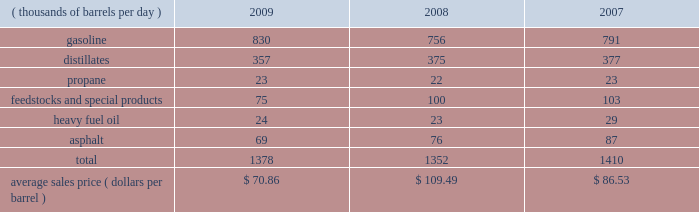The table sets forth our refined products sales by product group and our average sales price for each of the last three years .
Refined product sales ( thousands of barrels per day ) 2009 2008 2007 .
We sell gasoline , gasoline blendstocks and no .
1 and no .
2 fuel oils ( including kerosene , jet fuel and diesel fuel ) to wholesale marketing customers in the midwest , upper great plains , gulf coast and southeastern regions of the united states .
We sold 51 percent of our gasoline volumes and 87 percent of our distillates volumes on a wholesale or spot market basis in 2009 .
The demand for gasoline is seasonal in many of our markets , with demand typically being at its highest levels during the summer months .
We have blended ethanol into gasoline for over 20 years and began expanding our blending program in 2007 , in part due to federal regulations that require us to use specified volumes of renewable fuels .
Ethanol volumes sold in blended gasoline were 60 mbpd in 2009 , 54 mbpd in 2008 and 40 mbpd in 2007 .
The future expansion or contraction of our ethanol blending program will be driven by the economics of the ethanol supply and by government regulations .
We sell reformulated gasoline , which is also blended with ethanol , in parts of our marketing territory , including : chicago , illinois ; louisville , kentucky ; northern kentucky ; milwaukee , wisconsin , and hartford , illinois .
We also sell biodiesel-blended diesel in minnesota , illinois and kentucky .
We produce propane at all seven of our refineries .
Propane is primarily used for home heating and cooking , as a feedstock within the petrochemical industry , for grain drying and as a fuel for trucks and other vehicles .
Our propane sales are typically split evenly between the home heating market and industrial consumers .
We are a producer and marketer of petrochemicals and specialty products .
Product availability varies by refinery and includes benzene , cumene , dilute naphthalene oil , molten maleic anhydride , molten sulfur , propylene , toluene and xylene .
We market propylene , cumene and sulfur domestically to customers in the chemical industry .
We sell maleic anhydride throughout the united states and canada .
We also have the capacity to produce 1400 tons per day of anode grade coke at our robinson refinery , which is used to make carbon anodes for the aluminum smelting industry , and 5500 tons per day of fuel grade coke at the garyville refinery , which is used for power generation and in miscellaneous industrial applications .
In early 2009 , we discontinued production and sales of petroleum pitch and aliphatic solvents at our catlettsburg refinery .
We produce and market heavy residual fuel oil or related components at all seven of our refineries .
Another product of crude oil , heavy residual fuel oil , is primarily used in the utility and ship bunkering ( fuel ) industries , though there are other more specialized uses of the product .
We have refinery based asphalt production capacity of up to 108 mbpd .
We market asphalt through 33 owned or leased terminals throughout the midwest and southeast .
We have a broad customer base , including approximately 675 asphalt-paving contractors , government entities ( states , counties , cities and townships ) and asphalt roofing shingle manufacturers .
We sell asphalt in the wholesale and cargo markets via rail and barge .
We also produce asphalt cements , polymer modified asphalt , emulsified asphalt and industrial asphalts .
In 2007 , we acquired a 35 percent interest in an entity which owns and operates a 110-million-gallon-per-year ethanol production facility in clymers , indiana .
We also own a 50 percent interest in an entity which owns a 110-million-gallon-per-year ethanol production facility in greenville , ohio .
The greenville plant began production in february 2008 .
Both of these facilities are managed by a co-owner. .
In thousands of bbl per day , what was average gasoline production during the three year period? 
Computations: table_average(gasoline, none)
Answer: 792.33333. 